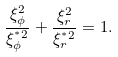<formula> <loc_0><loc_0><loc_500><loc_500>\frac { \xi _ { \phi } ^ { 2 } } { \xi _ { \phi } ^ { ^ { * } 2 } } + \frac { \xi _ { r } ^ { 2 } } { \xi _ { r } ^ { ^ { * } 2 } } = 1 .</formula> 